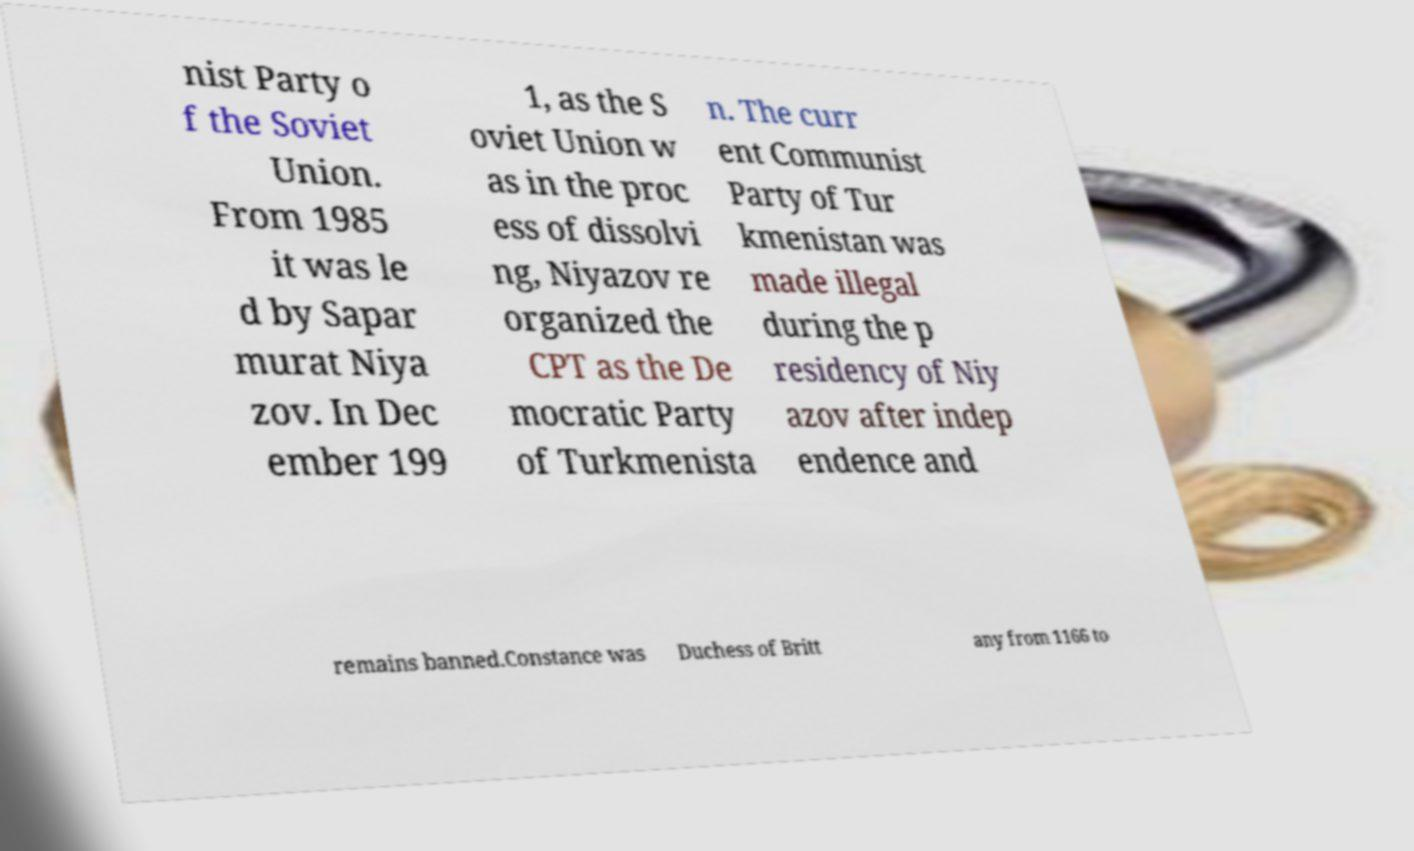Can you accurately transcribe the text from the provided image for me? nist Party o f the Soviet Union. From 1985 it was le d by Sapar murat Niya zov. In Dec ember 199 1, as the S oviet Union w as in the proc ess of dissolvi ng, Niyazov re organized the CPT as the De mocratic Party of Turkmenista n. The curr ent Communist Party of Tur kmenistan was made illegal during the p residency of Niy azov after indep endence and remains banned.Constance was Duchess of Britt any from 1166 to 